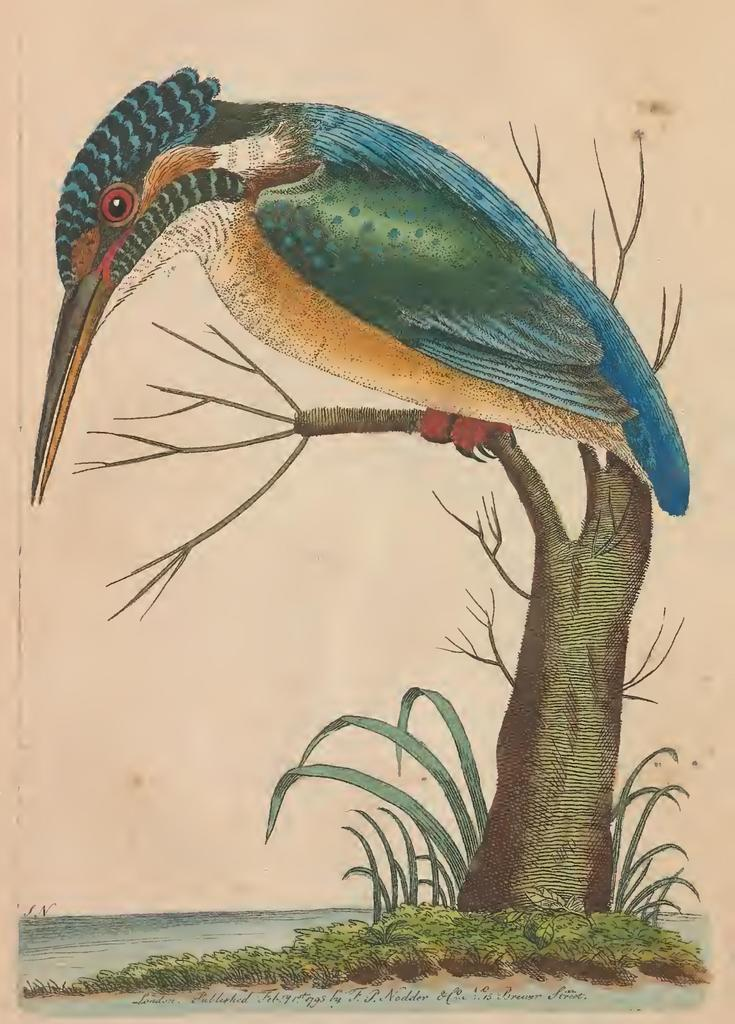What type of artwork is depicted in the image? The image is a painting. What natural element can be seen in the painting? There is a tree in the painting. What animal is perched on the tree? There is a bird on the tree. What type of ground is visible at the bottom of the painting? There is grass at the bottom of the painting. What body of water can be seen in the painting? There is water visible in the painting. What type of watch is the donkey wearing in the painting? There is no donkey or watch present in the painting. 